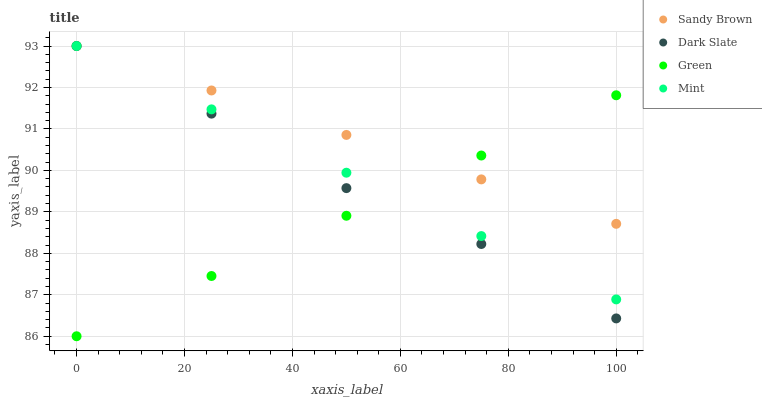Does Green have the minimum area under the curve?
Answer yes or no. Yes. Does Sandy Brown have the maximum area under the curve?
Answer yes or no. Yes. Does Sandy Brown have the minimum area under the curve?
Answer yes or no. No. Does Green have the maximum area under the curve?
Answer yes or no. No. Is Sandy Brown the smoothest?
Answer yes or no. Yes. Is Dark Slate the roughest?
Answer yes or no. Yes. Is Green the smoothest?
Answer yes or no. No. Is Green the roughest?
Answer yes or no. No. Does Green have the lowest value?
Answer yes or no. Yes. Does Sandy Brown have the lowest value?
Answer yes or no. No. Does Mint have the highest value?
Answer yes or no. Yes. Does Green have the highest value?
Answer yes or no. No. Does Dark Slate intersect Green?
Answer yes or no. Yes. Is Dark Slate less than Green?
Answer yes or no. No. Is Dark Slate greater than Green?
Answer yes or no. No. 